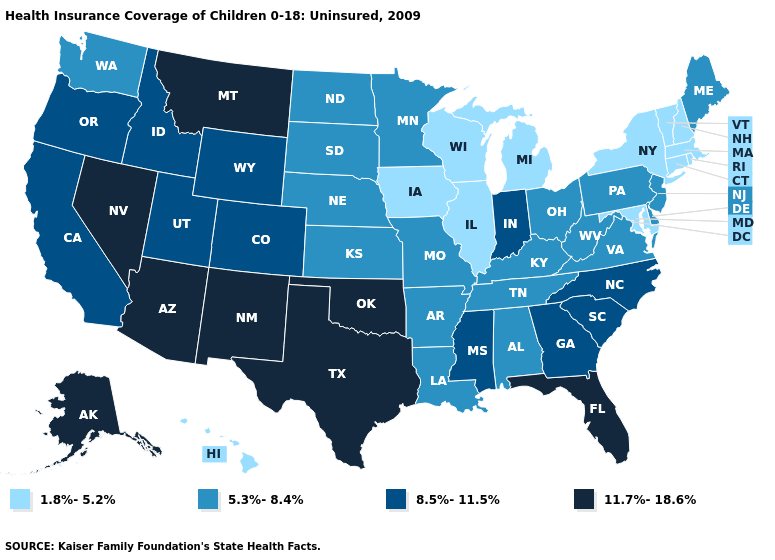Does Oregon have the same value as West Virginia?
Be succinct. No. Name the states that have a value in the range 5.3%-8.4%?
Short answer required. Alabama, Arkansas, Delaware, Kansas, Kentucky, Louisiana, Maine, Minnesota, Missouri, Nebraska, New Jersey, North Dakota, Ohio, Pennsylvania, South Dakota, Tennessee, Virginia, Washington, West Virginia. What is the value of Kansas?
Concise answer only. 5.3%-8.4%. Does Alaska have the highest value in the USA?
Short answer required. Yes. How many symbols are there in the legend?
Short answer required. 4. What is the lowest value in the MidWest?
Write a very short answer. 1.8%-5.2%. What is the highest value in the USA?
Answer briefly. 11.7%-18.6%. Does Wyoming have the same value as Delaware?
Concise answer only. No. Which states have the highest value in the USA?
Concise answer only. Alaska, Arizona, Florida, Montana, Nevada, New Mexico, Oklahoma, Texas. Which states have the lowest value in the South?
Answer briefly. Maryland. Does Montana have the same value as Hawaii?
Be succinct. No. What is the value of Alabama?
Answer briefly. 5.3%-8.4%. Does the map have missing data?
Be succinct. No. Among the states that border Florida , does Georgia have the highest value?
Answer briefly. Yes. Name the states that have a value in the range 1.8%-5.2%?
Keep it brief. Connecticut, Hawaii, Illinois, Iowa, Maryland, Massachusetts, Michigan, New Hampshire, New York, Rhode Island, Vermont, Wisconsin. 